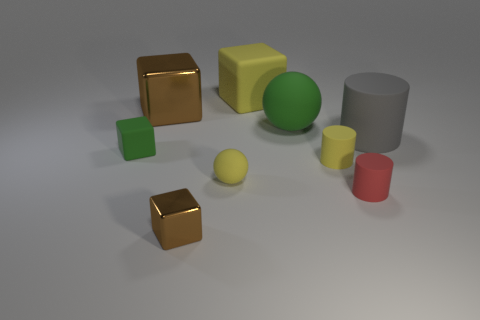What shape is the big rubber object that is the same color as the tiny matte sphere?
Ensure brevity in your answer.  Cube. Are the big green ball and the gray cylinder made of the same material?
Ensure brevity in your answer.  Yes. What number of large green matte spheres are to the left of the large brown block?
Your answer should be compact. 0. There is a yellow object that is both in front of the small matte block and right of the small sphere; what is its material?
Give a very brief answer. Rubber. What number of blocks are blue metal objects or red things?
Ensure brevity in your answer.  0. What is the material of the other big object that is the same shape as the big brown metal object?
Your answer should be compact. Rubber. What is the size of the yellow sphere that is made of the same material as the yellow cylinder?
Keep it short and to the point. Small. Do the brown metallic object that is behind the big green rubber sphere and the green matte thing behind the big gray rubber cylinder have the same shape?
Ensure brevity in your answer.  No. There is a tiny cylinder that is made of the same material as the red thing; what is its color?
Ensure brevity in your answer.  Yellow. Does the brown block that is in front of the red matte thing have the same size as the brown thing that is behind the green matte sphere?
Provide a succinct answer. No. 